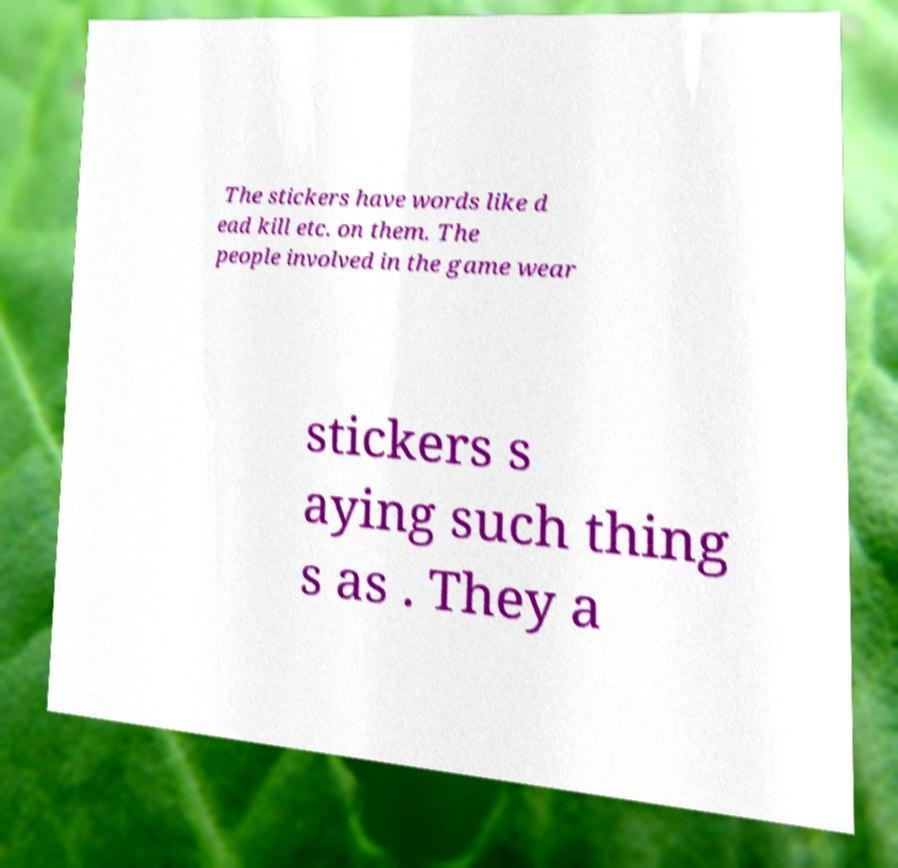What messages or text are displayed in this image? I need them in a readable, typed format. The stickers have words like d ead kill etc. on them. The people involved in the game wear stickers s aying such thing s as . They a 